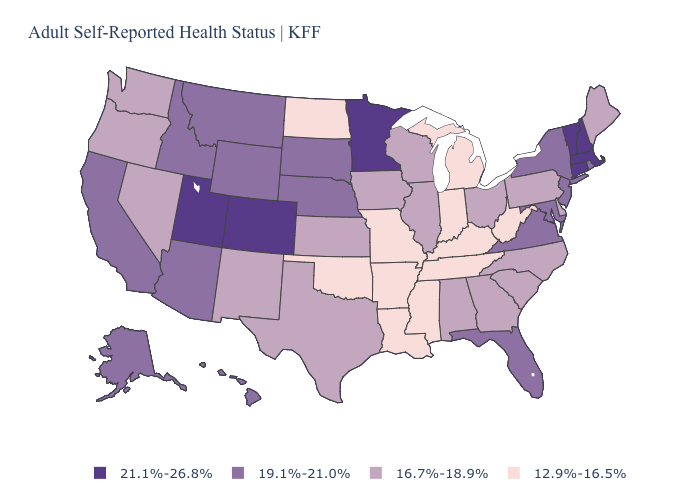Does Washington have a lower value than Missouri?
Quick response, please. No. What is the value of Maryland?
Write a very short answer. 19.1%-21.0%. Name the states that have a value in the range 12.9%-16.5%?
Quick response, please. Arkansas, Indiana, Kentucky, Louisiana, Michigan, Mississippi, Missouri, North Dakota, Oklahoma, Tennessee, West Virginia. Which states have the highest value in the USA?
Quick response, please. Colorado, Connecticut, Massachusetts, Minnesota, New Hampshire, Utah, Vermont. What is the lowest value in states that border Kentucky?
Short answer required. 12.9%-16.5%. Which states have the lowest value in the Northeast?
Quick response, please. Maine, Pennsylvania. Which states hav the highest value in the West?
Give a very brief answer. Colorado, Utah. Name the states that have a value in the range 12.9%-16.5%?
Be succinct. Arkansas, Indiana, Kentucky, Louisiana, Michigan, Mississippi, Missouri, North Dakota, Oklahoma, Tennessee, West Virginia. Name the states that have a value in the range 21.1%-26.8%?
Be succinct. Colorado, Connecticut, Massachusetts, Minnesota, New Hampshire, Utah, Vermont. Does Idaho have the lowest value in the West?
Be succinct. No. What is the highest value in the USA?
Give a very brief answer. 21.1%-26.8%. Name the states that have a value in the range 12.9%-16.5%?
Answer briefly. Arkansas, Indiana, Kentucky, Louisiana, Michigan, Mississippi, Missouri, North Dakota, Oklahoma, Tennessee, West Virginia. Name the states that have a value in the range 21.1%-26.8%?
Concise answer only. Colorado, Connecticut, Massachusetts, Minnesota, New Hampshire, Utah, Vermont. Among the states that border South Dakota , which have the lowest value?
Short answer required. North Dakota. Name the states that have a value in the range 12.9%-16.5%?
Concise answer only. Arkansas, Indiana, Kentucky, Louisiana, Michigan, Mississippi, Missouri, North Dakota, Oklahoma, Tennessee, West Virginia. 